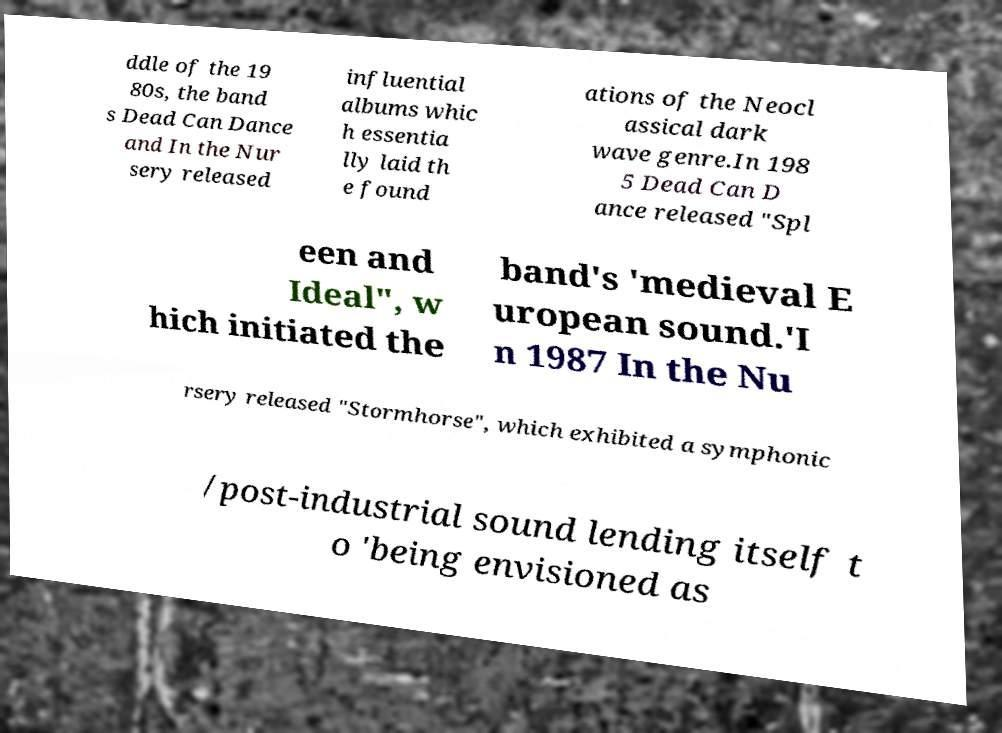Could you extract and type out the text from this image? ddle of the 19 80s, the band s Dead Can Dance and In the Nur sery released influential albums whic h essentia lly laid th e found ations of the Neocl assical dark wave genre.In 198 5 Dead Can D ance released "Spl een and Ideal", w hich initiated the band's 'medieval E uropean sound.'I n 1987 In the Nu rsery released "Stormhorse", which exhibited a symphonic /post-industrial sound lending itself t o 'being envisioned as 